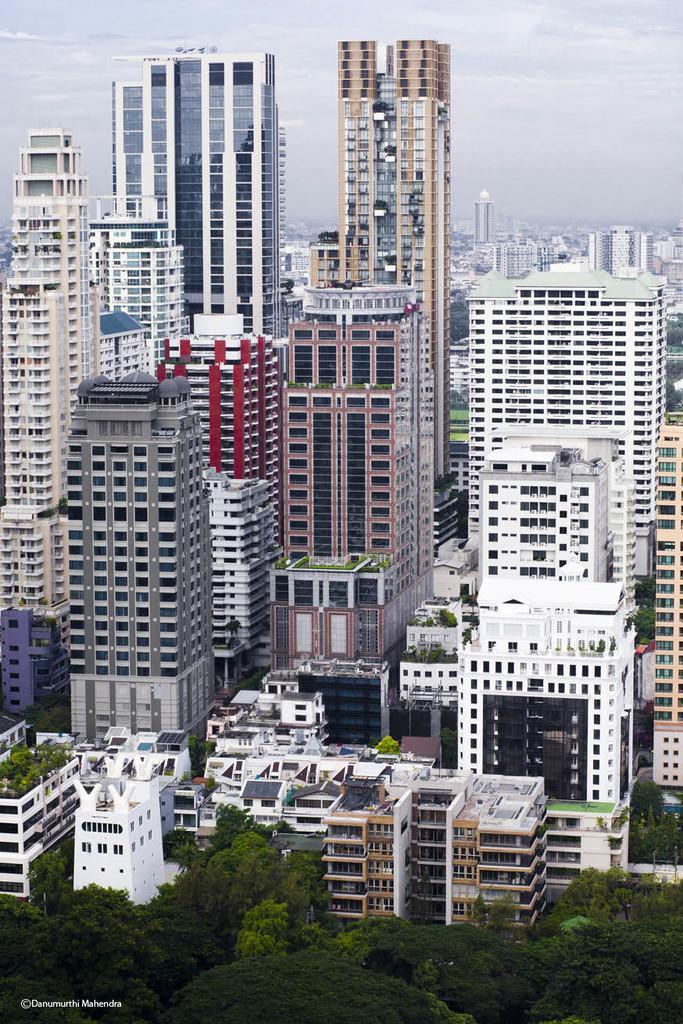Can you describe this image briefly? In this picture we can see few trees, buildings and clouds, in the bottom left hand corner we can see some text. 